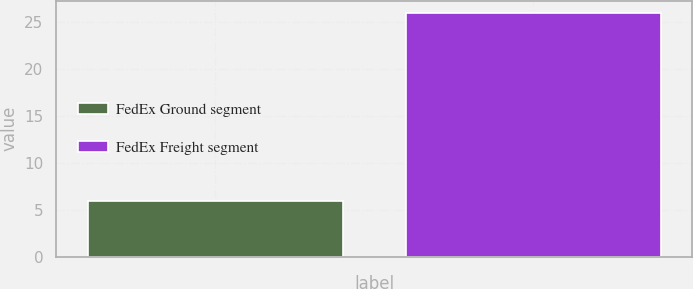Convert chart to OTSL. <chart><loc_0><loc_0><loc_500><loc_500><bar_chart><fcel>FedEx Ground segment<fcel>FedEx Freight segment<nl><fcel>6<fcel>26<nl></chart> 